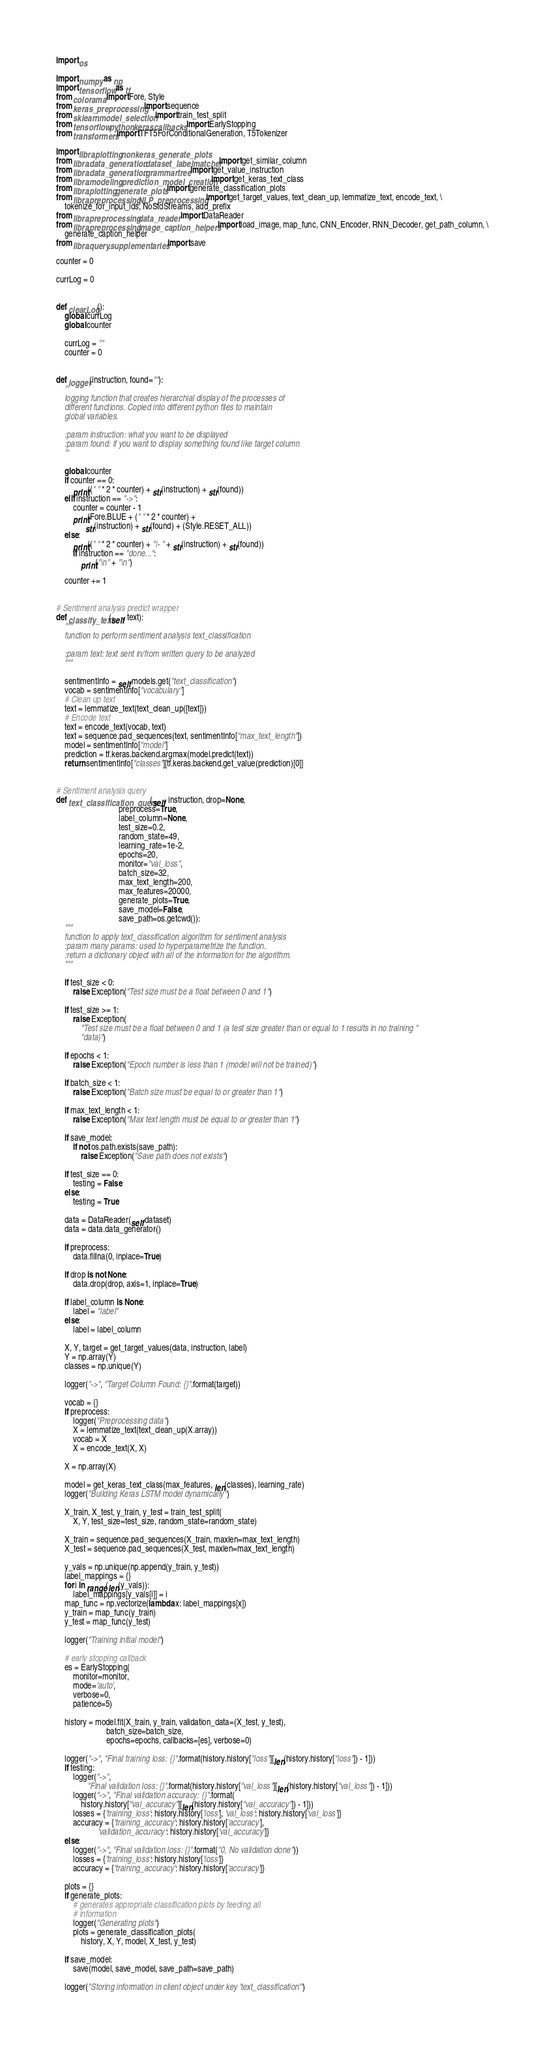<code> <loc_0><loc_0><loc_500><loc_500><_Python_>import os

import numpy as np
import tensorflow as tf
from colorama import Fore, Style
from keras_preprocessing import sequence
from sklearn.model_selection import train_test_split
from tensorflow.python.keras.callbacks import EarlyStopping
from transformers import TFT5ForConditionalGeneration, T5Tokenizer

import libra.plotting.nonkeras_generate_plots
from libra.data_generation.dataset_labelmatcher import get_similar_column
from libra.data_generation.grammartree import get_value_instruction
from libra.modeling.prediction_model_creation import get_keras_text_class
from libra.plotting.generate_plots import generate_classification_plots
from libra.preprocessing.NLP_preprocessing import get_target_values, text_clean_up, lemmatize_text, encode_text, \
    tokenize_for_input_ids, NoStdStreams, add_prefix
from libra.preprocessing.data_reader import DataReader
from libra.preprocessing.image_caption_helpers import load_image, map_func, CNN_Encoder, RNN_Decoder, get_path_column, \
    generate_caption_helper
from libra.query.supplementaries import save

counter = 0

currLog = 0


def clearLog():
    global currLog
    global counter

    currLog = ""
    counter = 0


def logger(instruction, found=""):
    '''
    logging function that creates hierarchial display of the processes of
    different functions. Copied into different python files to maintain
    global variables.

    :param instruction: what you want to be displayed
    :param found: if you want to display something found like target column
    '''

    global counter
    if counter == 0:
        print((" " * 2 * counter) + str(instruction) + str(found))
    elif instruction == "->":
        counter = counter - 1
        print(Fore.BLUE + (" " * 2 * counter) +
              str(instruction) + str(found) + (Style.RESET_ALL))
    else:
        print((" " * 2 * counter) + "|- " + str(instruction) + str(found))
        if instruction == "done...":
            print("\n" + "\n")

    counter += 1


# Sentiment analysis predict wrapper
def classify_text(self, text):
    """
    function to perform sentiment analysis text_classification

    :param text: text sent in/from written query to be analyzed
    """

    sentimentInfo = self.models.get("text_classification")
    vocab = sentimentInfo["vocabulary"]
    # Clean up text
    text = lemmatize_text(text_clean_up([text]))
    # Encode text
    text = encode_text(vocab, text)
    text = sequence.pad_sequences(text, sentimentInfo["max_text_length"])
    model = sentimentInfo["model"]
    prediction = tf.keras.backend.argmax(model.predict(text))
    return sentimentInfo["classes"][tf.keras.backend.get_value(prediction)[0]]


# Sentiment analysis query
def text_classification_query(self, instruction, drop=None,
                              preprocess=True,
                              label_column=None,
                              test_size=0.2,
                              random_state=49,
                              learning_rate=1e-2,
                              epochs=20,
                              monitor="val_loss",
                              batch_size=32,
                              max_text_length=200,
                              max_features=20000,
                              generate_plots=True,
                              save_model=False,
                              save_path=os.getcwd()):
    """
    function to apply text_classification algorithm for sentiment analysis
    :param many params: used to hyperparametrize the function.
    :return a dictionary object with all of the information for the algorithm.
    """

    if test_size < 0:
        raise Exception("Test size must be a float between 0 and 1")

    if test_size >= 1:
        raise Exception(
            "Test size must be a float between 0 and 1 (a test size greater than or equal to 1 results in no training "
            "data)")

    if epochs < 1:
        raise Exception("Epoch number is less than 1 (model will not be trained)")

    if batch_size < 1:
        raise Exception("Batch size must be equal to or greater than 1")

    if max_text_length < 1:
        raise Exception("Max text length must be equal to or greater than 1")

    if save_model:
        if not os.path.exists(save_path):
            raise Exception("Save path does not exists")

    if test_size == 0:
        testing = False
    else:
        testing = True

    data = DataReader(self.dataset)
    data = data.data_generator()

    if preprocess:
        data.fillna(0, inplace=True)

    if drop is not None:
        data.drop(drop, axis=1, inplace=True)

    if label_column is None:
        label = "label"
    else:
        label = label_column

    X, Y, target = get_target_values(data, instruction, label)
    Y = np.array(Y)
    classes = np.unique(Y)

    logger("->", "Target Column Found: {}".format(target))

    vocab = {}
    if preprocess:
        logger("Preprocessing data")
        X = lemmatize_text(text_clean_up(X.array))
        vocab = X
        X = encode_text(X, X)

    X = np.array(X)

    model = get_keras_text_class(max_features, len(classes), learning_rate)
    logger("Building Keras LSTM model dynamically")

    X_train, X_test, y_train, y_test = train_test_split(
        X, Y, test_size=test_size, random_state=random_state)

    X_train = sequence.pad_sequences(X_train, maxlen=max_text_length)
    X_test = sequence.pad_sequences(X_test, maxlen=max_text_length)

    y_vals = np.unique(np.append(y_train, y_test))
    label_mappings = {}
    for i in range(len(y_vals)):
        label_mappings[y_vals[i]] = i
    map_func = np.vectorize(lambda x: label_mappings[x])
    y_train = map_func(y_train)
    y_test = map_func(y_test)

    logger("Training initial model")

    # early stopping callback
    es = EarlyStopping(
        monitor=monitor,
        mode='auto',
        verbose=0,
        patience=5)

    history = model.fit(X_train, y_train, validation_data=(X_test, y_test),
                        batch_size=batch_size,
                        epochs=epochs, callbacks=[es], verbose=0)

    logger("->", "Final training loss: {}".format(history.history["loss"][len(history.history["loss"]) - 1]))
    if testing:
        logger("->",
               "Final validation loss: {}".format(history.history["val_loss"][len(history.history["val_loss"]) - 1]))
        logger("->", "Final validation accuracy: {}".format(
            history.history["val_accuracy"][len(history.history["val_accuracy"]) - 1]))
        losses = {'training_loss': history.history['loss'], 'val_loss': history.history['val_loss']}
        accuracy = {'training_accuracy': history.history['accuracy'],
                    'validation_accuracy': history.history['val_accuracy']}
    else:
        logger("->", "Final validation loss: {}".format("0, No validation done"))
        losses = {'training_loss': history.history['loss']}
        accuracy = {'training_accuracy': history.history['accuracy']}

    plots = {}
    if generate_plots:
        # generates appropriate classification plots by feeding all
        # information
        logger("Generating plots")
        plots = generate_classification_plots(
            history, X, Y, model, X_test, y_test)

    if save_model:
        save(model, save_model, save_path=save_path)

    logger("Storing information in client object under key 'text_classification'")</code> 